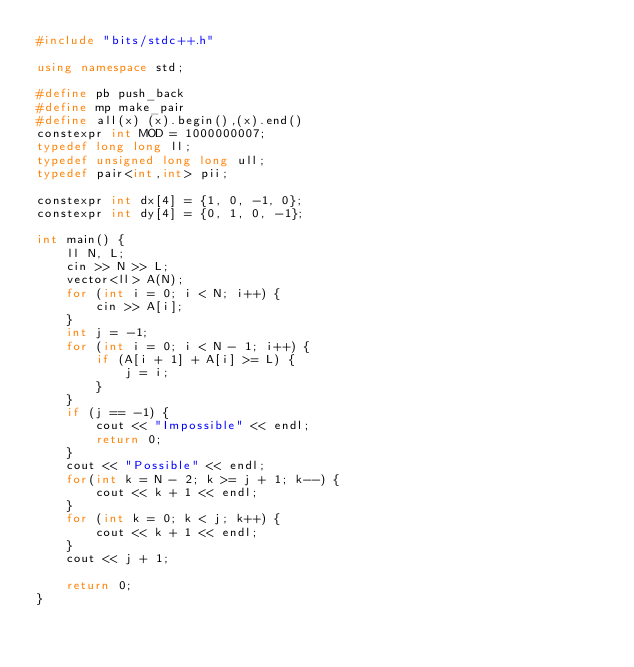<code> <loc_0><loc_0><loc_500><loc_500><_C++_>#include "bits/stdc++.h"

using namespace std;

#define pb push_back
#define mp make_pair
#define all(x) (x).begin(),(x).end()
constexpr int MOD = 1000000007;
typedef long long ll;
typedef unsigned long long ull;
typedef pair<int,int> pii;

constexpr int dx[4] = {1, 0, -1, 0};
constexpr int dy[4] = {0, 1, 0, -1};

int main() {
    ll N, L;
    cin >> N >> L;
    vector<ll> A(N);
    for (int i = 0; i < N; i++) {
        cin >> A[i];
    }
    int j = -1;
    for (int i = 0; i < N - 1; i++) {
        if (A[i + 1] + A[i] >= L) {
            j = i;
        }
    }
    if (j == -1) {
        cout << "Impossible" << endl;
        return 0;
    }
    cout << "Possible" << endl;
    for(int k = N - 2; k >= j + 1; k--) {
        cout << k + 1 << endl;
    }
    for (int k = 0; k < j; k++) {
        cout << k + 1 << endl;
    }
    cout << j + 1;

    return 0;
}
</code> 